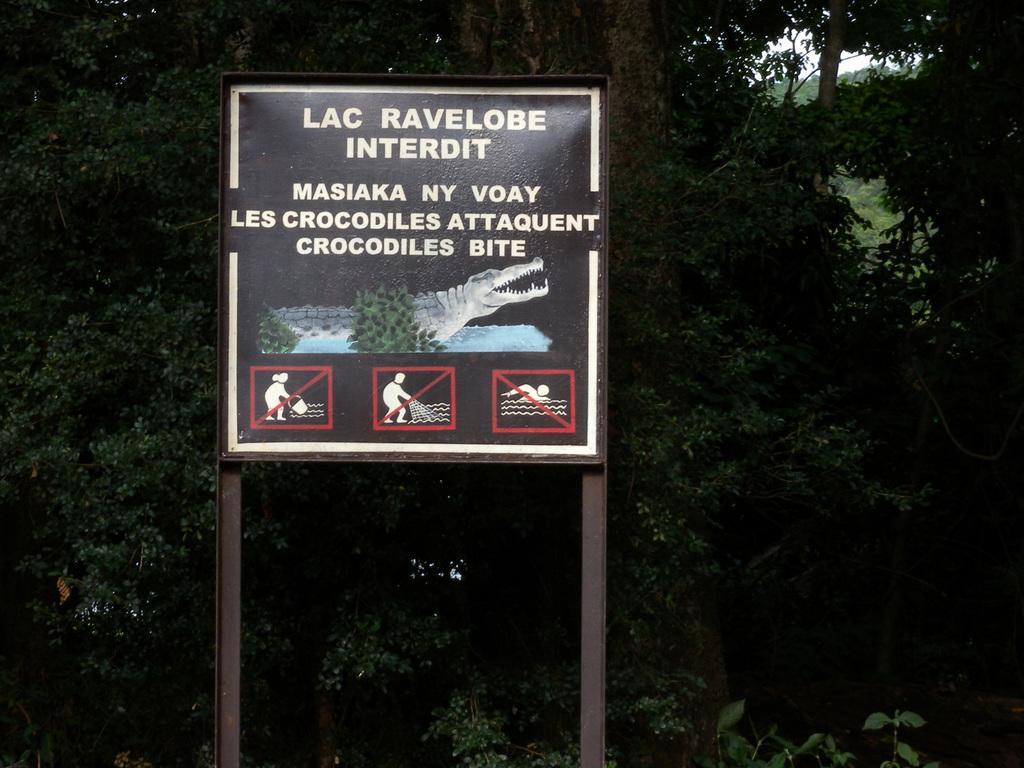How would you summarize this image in a sentence or two? As we can see in the image there is banner and trees. The image is little dark. 